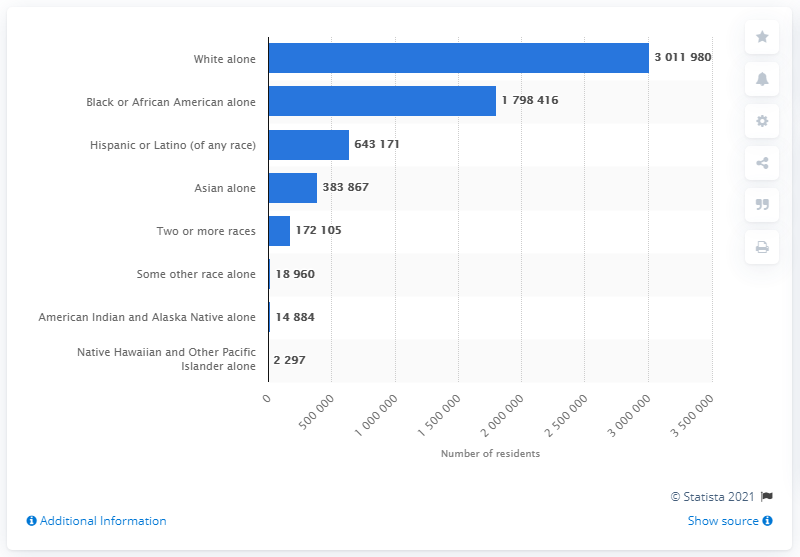List a handful of essential elements in this visual. In 2019, there were approximately 179,8416 people in Maryland who identified as Black or African American. 